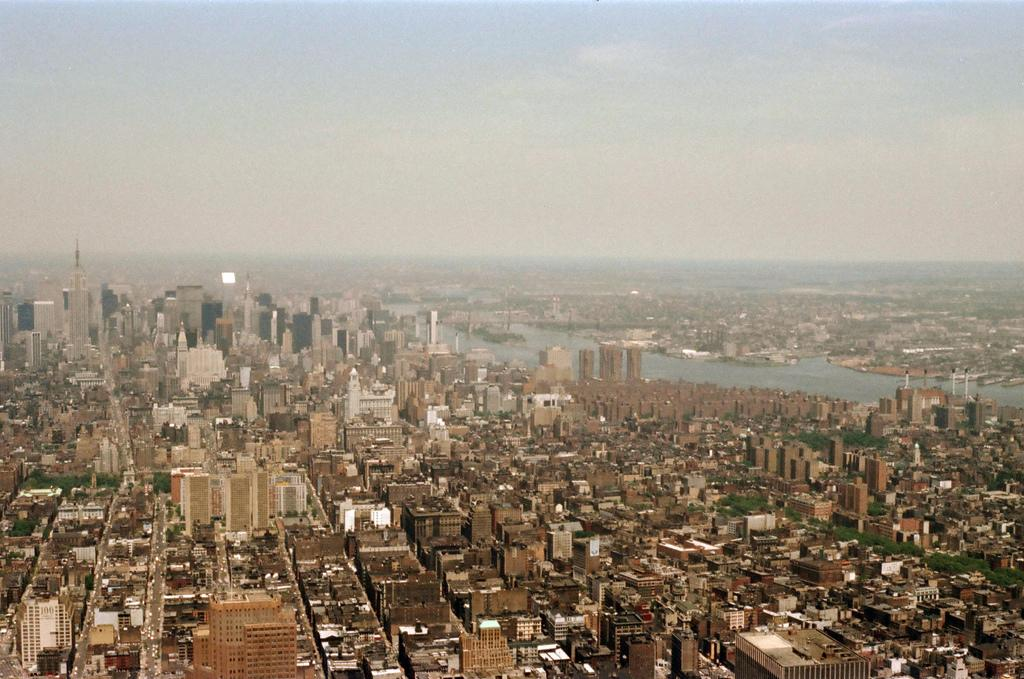What type of structures can be seen in the image? There are buildings and towers in the image. What other natural elements are present in the image? There are trees and water visible in the image. What is visible in the background of the image? The sky is visible in the image. Can you determine the time of day the image was taken? The image was likely taken during the day, as there is no indication of darkness or artificial lighting. What type of cup is being used to play volleyball in the image? There is no cup or volleyball present in the image. 